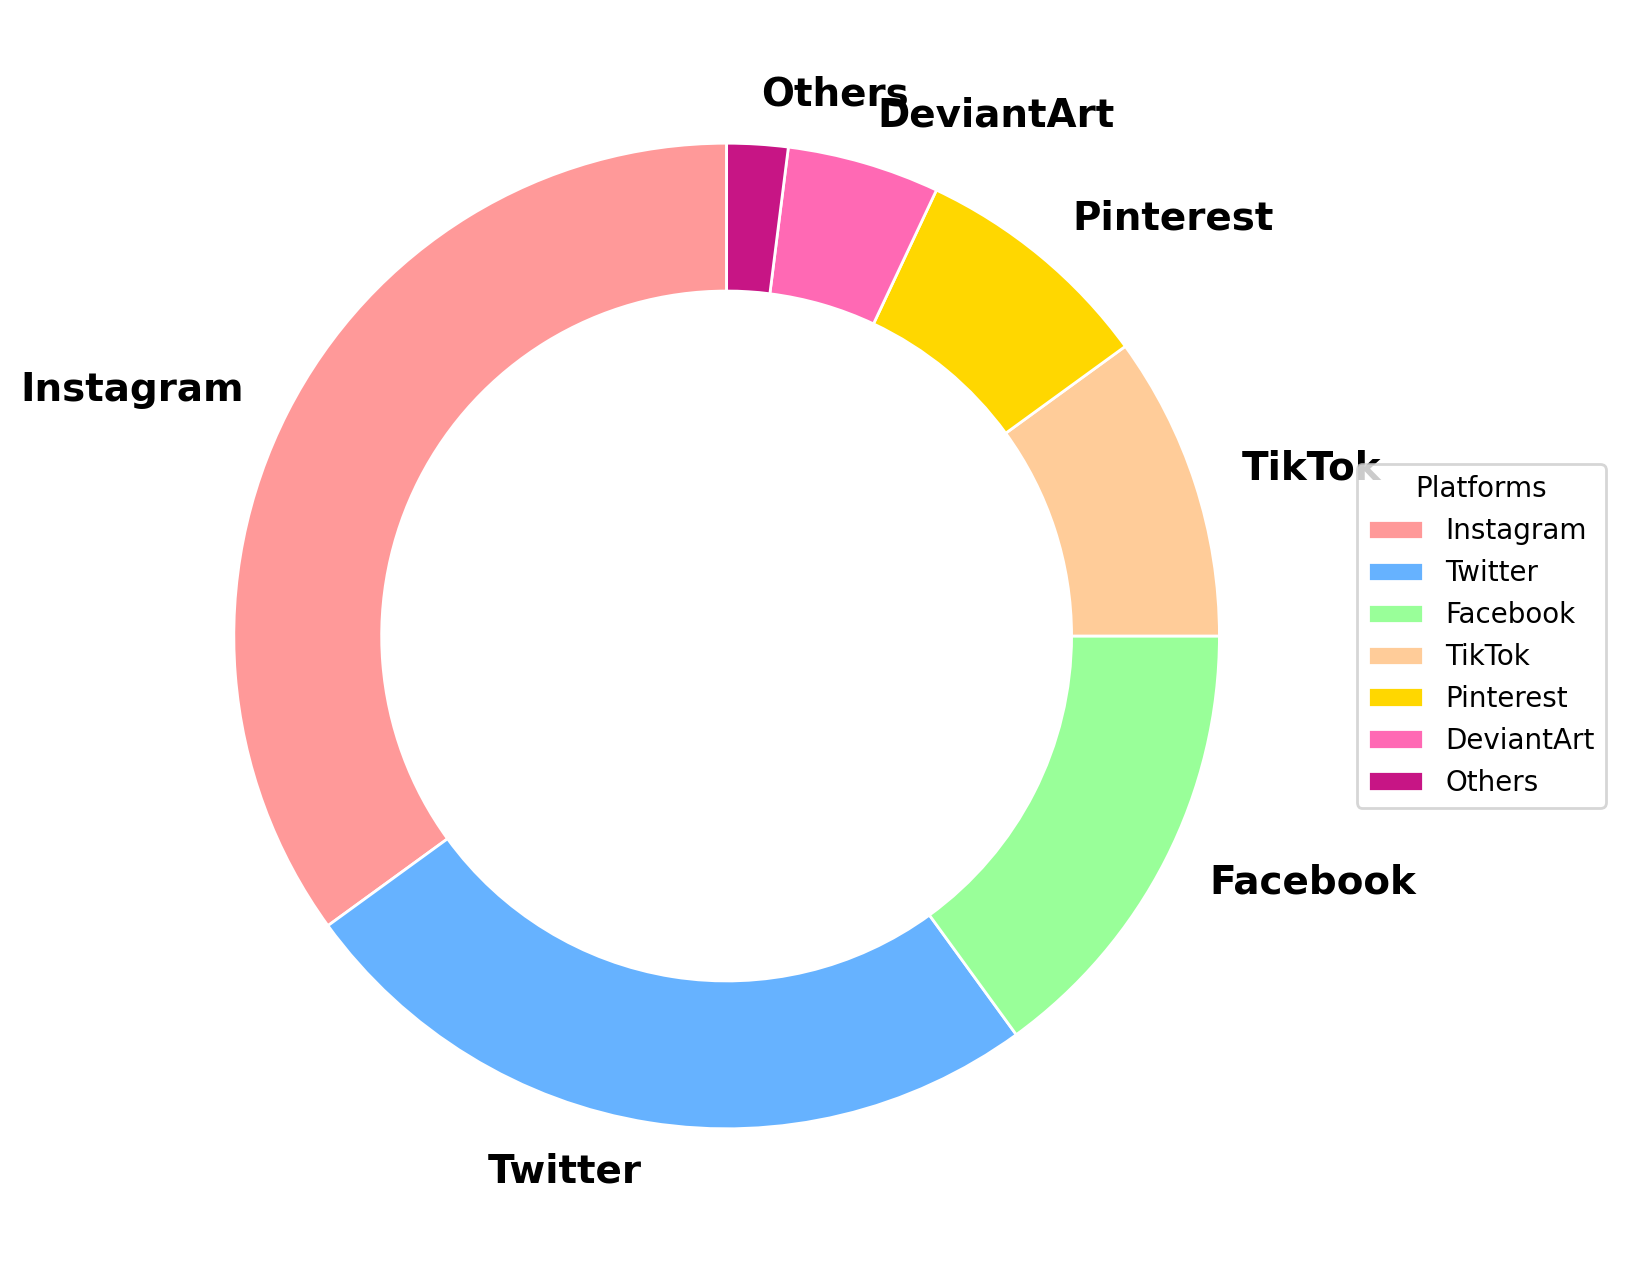What's the most popular social media platform for digital artists in Ontario? By looking at the largest segment in the ring chart, we can see that Instagram has the highest percentage.
Answer: Instagram What's the combined percentage of Facebook and TikTok usage among digital artists in Ontario? Facebook is 15%, and TikTok is 10%. Adding these together, we get 15% + 10% = 25%.
Answer: 25% Which platform has a greater percentage of usage, Pinterest or DeviantArt? Comparing the segments for Pinterest and DeviantArt, Pinterest has a larger segment with 8%, while DeviantArt has 5%.
Answer: Pinterest What proportion of the social media usage is accounted for by platforms other than Twitter, Facebook, and Instagram? Adding the percentages for TikTok, Pinterest, DeviantArt, and Others: 10% + 8% + 5% + 2% = 25%.
Answer: 25% What is the difference in percentage points between Instagram and Twitter? Instagram is at 35%, and Twitter is at 25%. The difference is 35% - 25% = 10%.
Answer: 10% How many platforms have a usage percentage greater than 10%? By examining the ring chart, Instagram (35%), Twitter (25%), and Facebook (15%) are greater than 10%. This counts to three platforms.
Answer: 3 Which platform appears in the smallest segment of the ring chart? The "Others" category, with 2%, appears as the smallest segment.
Answer: Others If a new survey shows that TikTok's usage has doubled while all other platforms remained the same, what would TikTok's new percentage be? TikTok's current percentage is 10%. If it doubles, it would be 10% * 2 = 20%.
Answer: 20% Comparing Instagram and TikTok, how much more popular is Instagram? Instagram has a percentage of 35%, and TikTok has 10%. The difference is 35% - 10% = 25%.
Answer: 25% What's the total percentage usage for Instagram, Twitter, and Facebook combined? Summing up the percentages for Instagram, Twitter, and Facebook: 35% + 25% + 15% = 75%.
Answer: 75% 